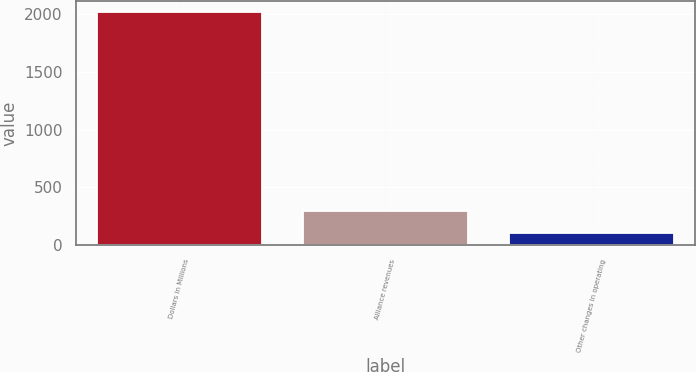<chart> <loc_0><loc_0><loc_500><loc_500><bar_chart><fcel>Dollars in Millions<fcel>Alliance revenues<fcel>Other changes in operating<nl><fcel>2013<fcel>299.4<fcel>109<nl></chart> 